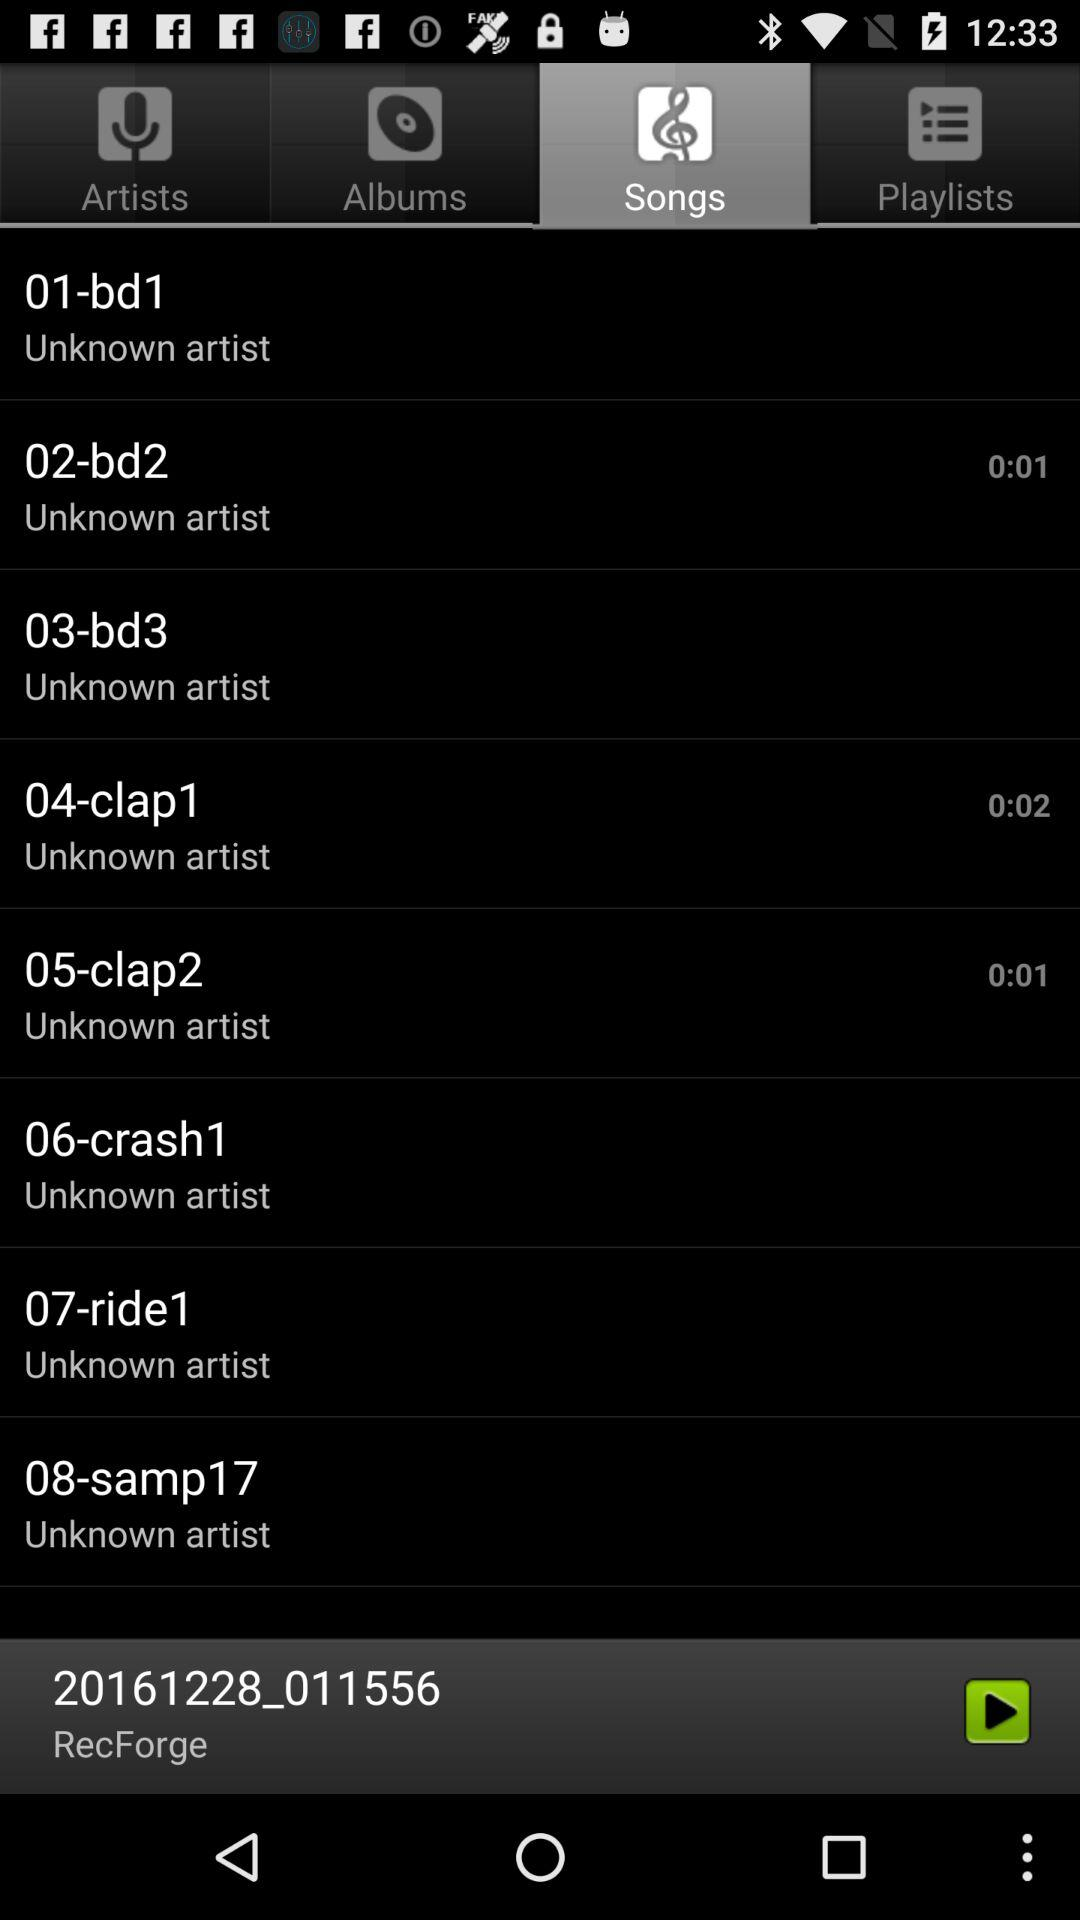Which tab is currently selected? The currently selected tab is "Songs". 